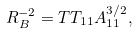<formula> <loc_0><loc_0><loc_500><loc_500>R _ { B } ^ { - 2 } = T T _ { 1 1 } A _ { 1 1 } ^ { 3 / 2 } ,</formula> 